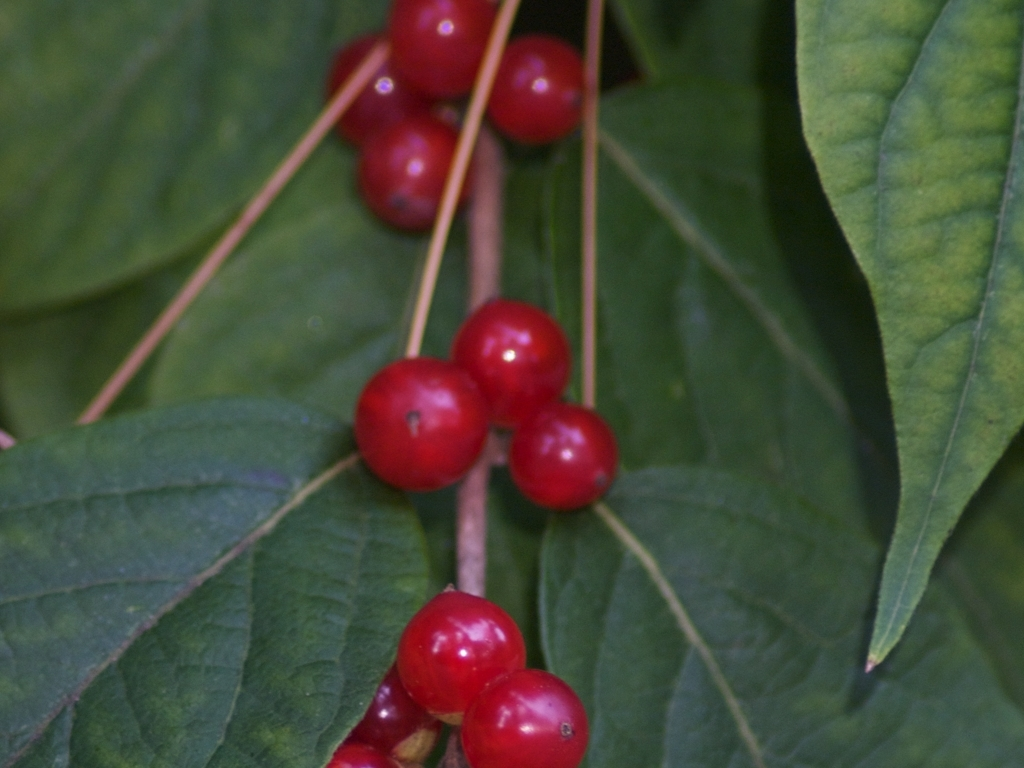Where might this plant typically be found? Plants like the one pictured, with vivid red berries, are commonly found in temperate forest regions. They could be part of an understorey plant community within a deciduous or mixed woodland. Their exact habitat can vary widely depending on the species, ranging from moist to dry conditions, in shaded or partly shaded areas. 